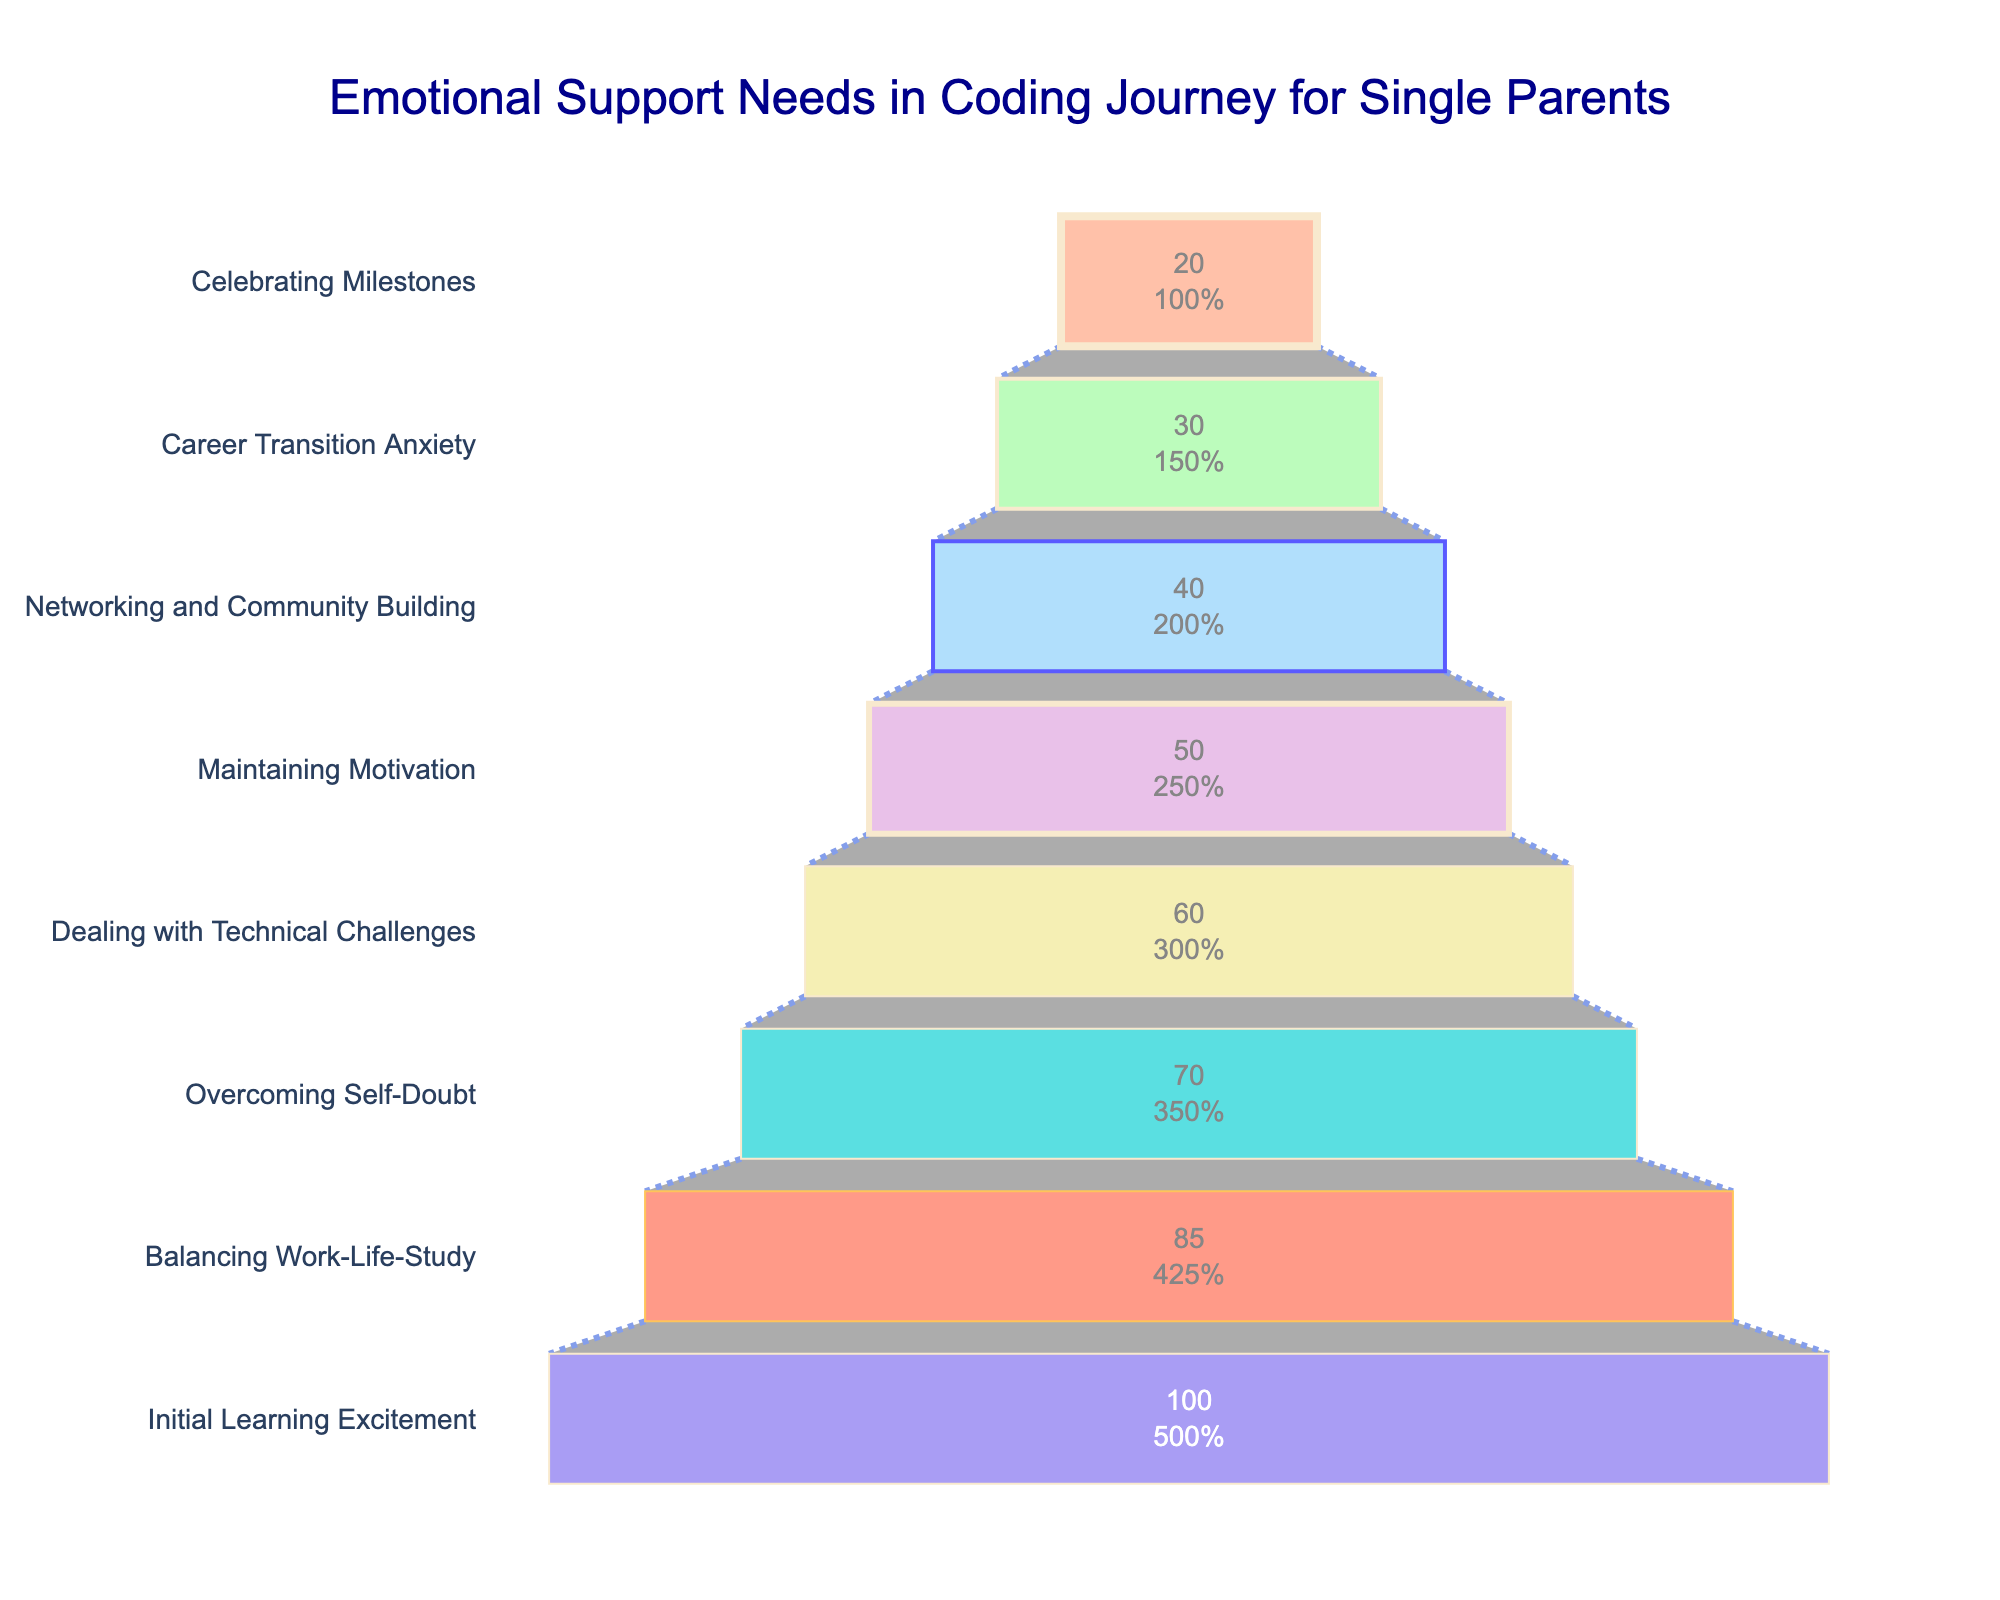what is the title of the funnel chart? The title of the funnel chart is located at the top and is written in a large, dark blue font.
Answer: Emotional Support Needs in Coding Journey for Single Parents How many phases are presented in the funnel chart? To determine the number of phases, count the distinct horizontal segments in the funnel chart.
Answer: 8 Which phase sees the largest drop in percentage from the previous phase? Compare the percentage difference between consecutive phases to find the largest drop. The steepest drop occurs between Balancing Work-Life-Study (85%) and Overcoming Self-Doubt (70%).
Answer: Balancing Work-Life-Study to Overcoming Self-Doubt What percentage of people experience emotional support needs during the 'Networking and Community Building' phase? Find the phase labeled 'Networking and Community Building' and refer to the percentage value associated with it.
Answer: 40% What is the combined percentage of people who need emotional support in 'Career Transition Anxiety' and 'Celebrating Milestones'? Add the percentage values for the phases 'Career Transition Anxiety' and 'Celebrating Milestones': 30% + 20% = 50%.
Answer: 50% Between which two phases is the drop in percentage the smallest? Compare the percentage differences between each consecutive phase. The smallest drop is between Overcoming Self-Doubt (70%) and Dealing with Technical Challenges (60%), which is a 10% difference.
Answer: Overcoming Self-Doubt and Dealing with Technical Challenges At what phase does the percentage of people needing emotional support fall below half of the initial value? Find when the percentage value drops below 50% of the initial value (100%). This happens at the 'Maintaining Motivation' phase, which is 50%.
Answer: Maintaining Motivation What is the color of the segment for the 'Dealing with Technical Challenges' phase? Identify the color associated with the 'Dealing with Technical Challenges' phase by looking at the funnel chart.
Answer: Purple (#DDA0DD) How much percentage does the 'Balancing Work-Life-Study' phase lose compared to the 'Initial Learning Excitement' phase? Subtract the percentage of 'Balancing Work-Life-Study' from 'Initial Learning Excitement': 100% - 85% = 15%.
Answer: 15% Which phase shows a greater support need: 'Networking and Community Building' or 'Career Transition Anxiety'? Directly compare the percentages listed for 'Networking and Community Building' (40%) and 'Career Transition Anxiety' (30%).
Answer: Networking and Community Building 